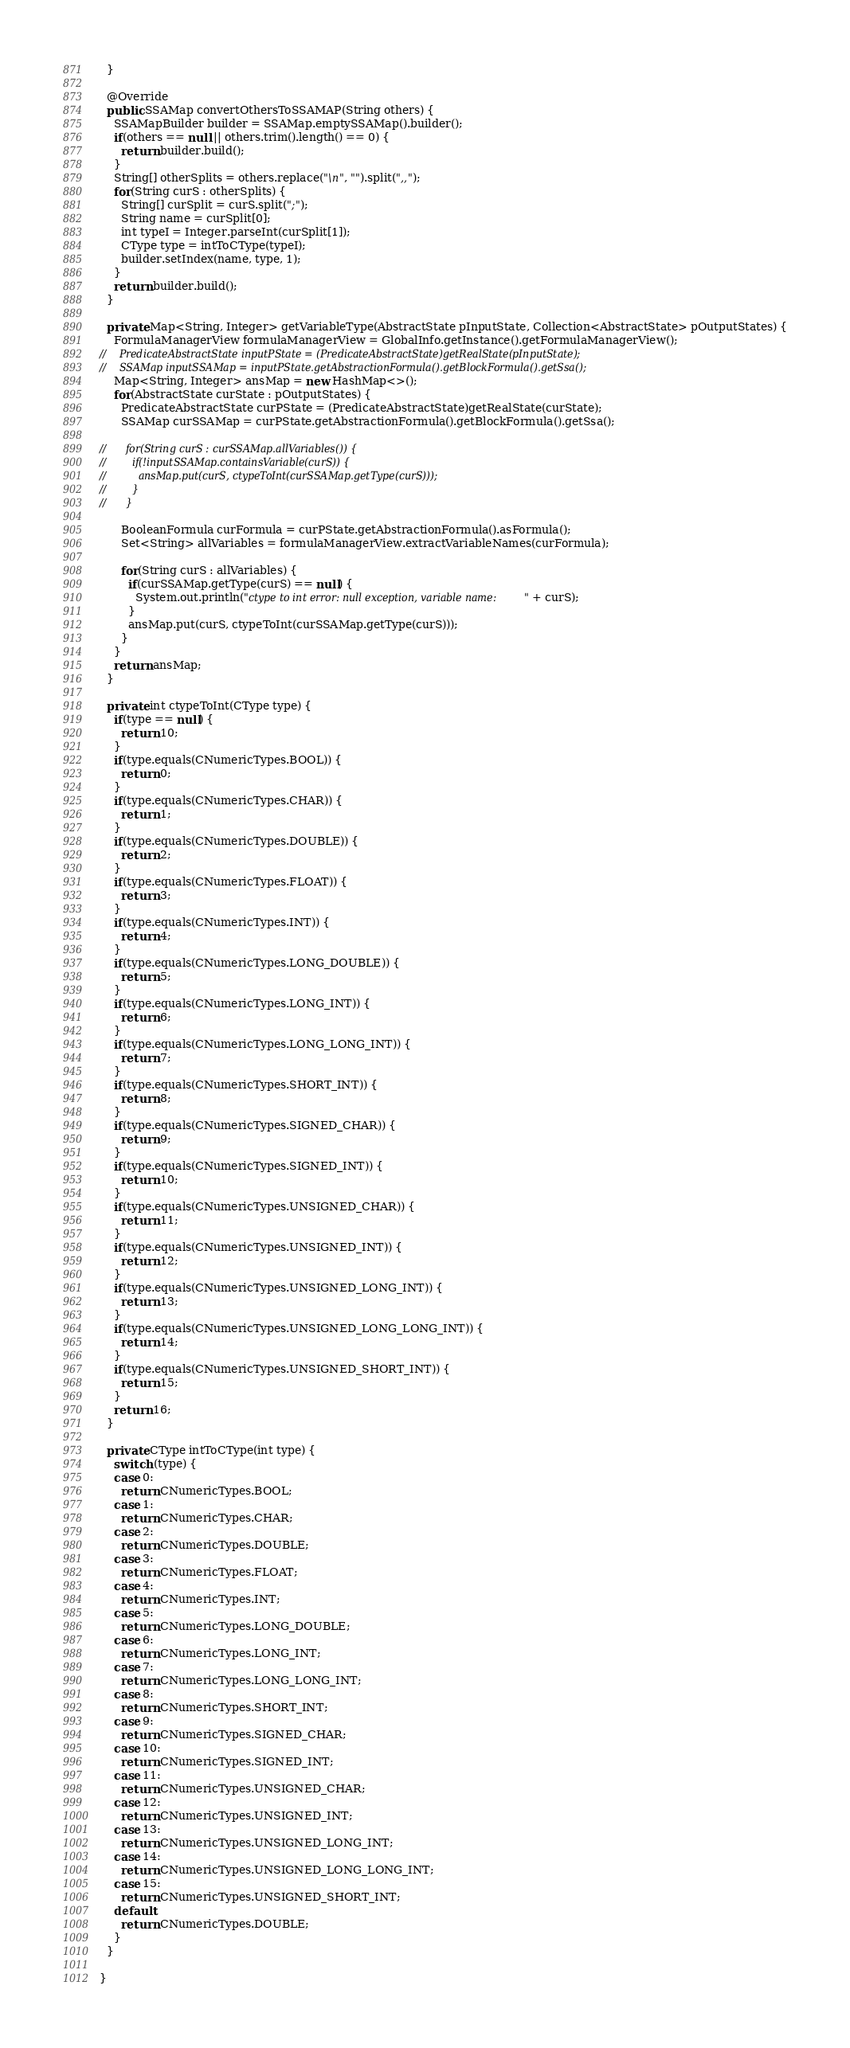Convert code to text. <code><loc_0><loc_0><loc_500><loc_500><_Java_>  }

  @Override
  public SSAMap convertOthersToSSAMAP(String others) {
    SSAMapBuilder builder = SSAMap.emptySSAMap().builder();
    if(others == null || others.trim().length() == 0) {
      return builder.build();
    }
    String[] otherSplits = others.replace("\n", "").split(",,");
    for(String curS : otherSplits) {
      String[] curSplit = curS.split(";");
      String name = curSplit[0];
      int typeI = Integer.parseInt(curSplit[1]);
      CType type = intToCType(typeI);
      builder.setIndex(name, type, 1);
    }
    return builder.build();
  }

  private Map<String, Integer> getVariableType(AbstractState pInputState, Collection<AbstractState> pOutputStates) {
    FormulaManagerView formulaManagerView = GlobalInfo.getInstance().getFormulaManagerView();
//    PredicateAbstractState inputPState = (PredicateAbstractState)getRealState(pInputState);
//    SSAMap inputSSAMap = inputPState.getAbstractionFormula().getBlockFormula().getSsa();
    Map<String, Integer> ansMap = new HashMap<>();
    for(AbstractState curState : pOutputStates) {
      PredicateAbstractState curPState = (PredicateAbstractState)getRealState(curState);
      SSAMap curSSAMap = curPState.getAbstractionFormula().getBlockFormula().getSsa();

//      for(String curS : curSSAMap.allVariables()) {
//        if(!inputSSAMap.containsVariable(curS)) {
//          ansMap.put(curS, ctypeToInt(curSSAMap.getType(curS)));
//        }
//      }

      BooleanFormula curFormula = curPState.getAbstractionFormula().asFormula();
      Set<String> allVariables = formulaManagerView.extractVariableNames(curFormula);

      for(String curS : allVariables) {
        if(curSSAMap.getType(curS) == null) {
          System.out.println("ctype to int error: null exception, variable name:" + curS);
        }
        ansMap.put(curS, ctypeToInt(curSSAMap.getType(curS)));
      }
    }
    return ansMap;
  }

  private int ctypeToInt(CType type) {
    if(type == null) {
      return 10;
    }
    if(type.equals(CNumericTypes.BOOL)) {
      return 0;
    }
    if(type.equals(CNumericTypes.CHAR)) {
      return 1;
    }
    if(type.equals(CNumericTypes.DOUBLE)) {
      return 2;
    }
    if(type.equals(CNumericTypes.FLOAT)) {
      return 3;
    }
    if(type.equals(CNumericTypes.INT)) {
      return 4;
    }
    if(type.equals(CNumericTypes.LONG_DOUBLE)) {
      return 5;
    }
    if(type.equals(CNumericTypes.LONG_INT)) {
      return 6;
    }
    if(type.equals(CNumericTypes.LONG_LONG_INT)) {
      return 7;
    }
    if(type.equals(CNumericTypes.SHORT_INT)) {
      return 8;
    }
    if(type.equals(CNumericTypes.SIGNED_CHAR)) {
      return 9;
    }
    if(type.equals(CNumericTypes.SIGNED_INT)) {
      return 10;
    }
    if(type.equals(CNumericTypes.UNSIGNED_CHAR)) {
      return 11;
    }
    if(type.equals(CNumericTypes.UNSIGNED_INT)) {
      return 12;
    }
    if(type.equals(CNumericTypes.UNSIGNED_LONG_INT)) {
      return 13;
    }
    if(type.equals(CNumericTypes.UNSIGNED_LONG_LONG_INT)) {
      return 14;
    }
    if(type.equals(CNumericTypes.UNSIGNED_SHORT_INT)) {
      return 15;
    }
    return 16;
  }

  private CType intToCType(int type) {
    switch (type) {
    case 0:
      return CNumericTypes.BOOL;
    case 1:
      return CNumericTypes.CHAR;
    case 2:
      return CNumericTypes.DOUBLE;
    case 3:
      return CNumericTypes.FLOAT;
    case 4:
      return CNumericTypes.INT;
    case 5:
      return CNumericTypes.LONG_DOUBLE;
    case 6:
      return CNumericTypes.LONG_INT;
    case 7:
      return CNumericTypes.LONG_LONG_INT;
    case 8:
      return CNumericTypes.SHORT_INT;
    case 9:
      return CNumericTypes.SIGNED_CHAR;
    case 10:
      return CNumericTypes.SIGNED_INT;
    case 11:
      return CNumericTypes.UNSIGNED_CHAR;
    case 12:
      return CNumericTypes.UNSIGNED_INT;
    case 13:
      return CNumericTypes.UNSIGNED_LONG_INT;
    case 14:
      return CNumericTypes.UNSIGNED_LONG_LONG_INT;
    case 15:
      return CNumericTypes.UNSIGNED_SHORT_INT;
    default:
      return CNumericTypes.DOUBLE;
    }
  }

}
</code> 